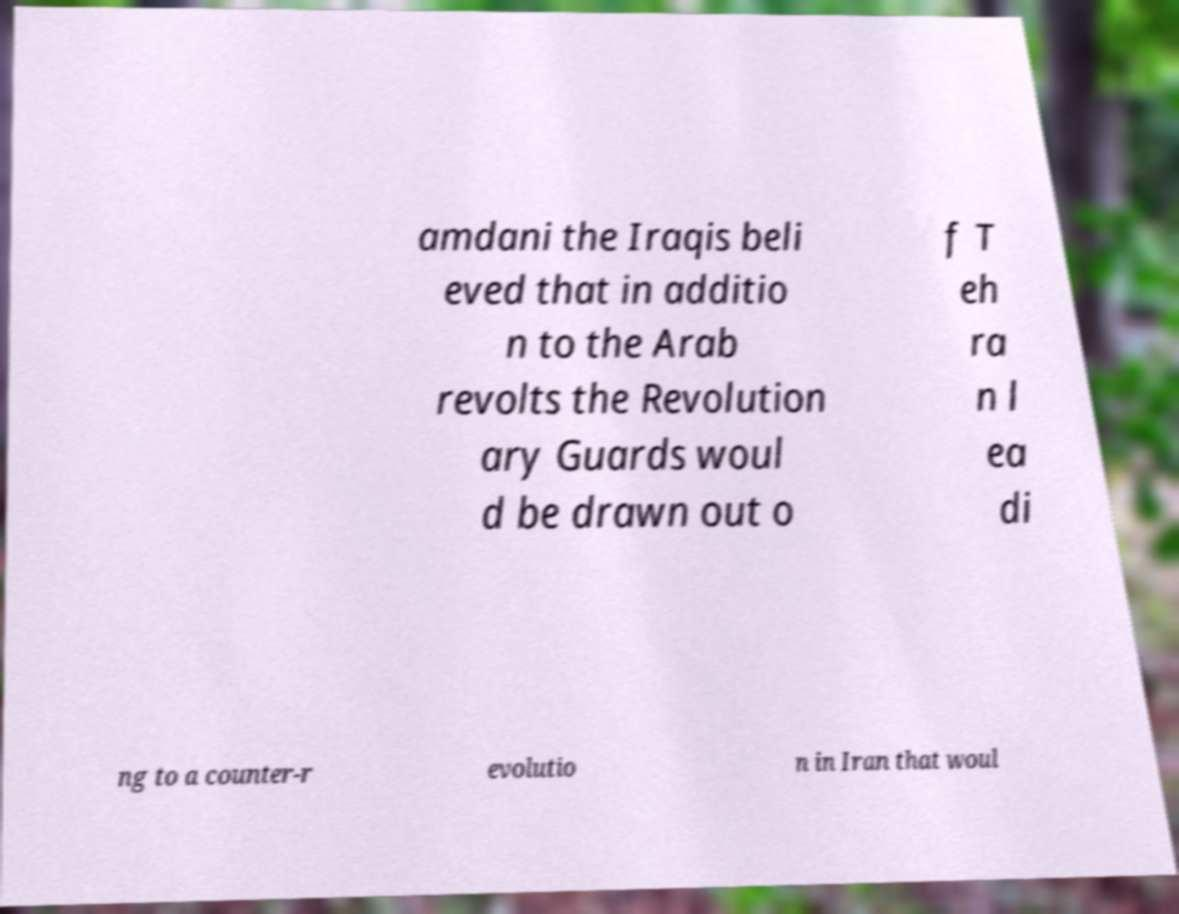Could you assist in decoding the text presented in this image and type it out clearly? amdani the Iraqis beli eved that in additio n to the Arab revolts the Revolution ary Guards woul d be drawn out o f T eh ra n l ea di ng to a counter-r evolutio n in Iran that woul 